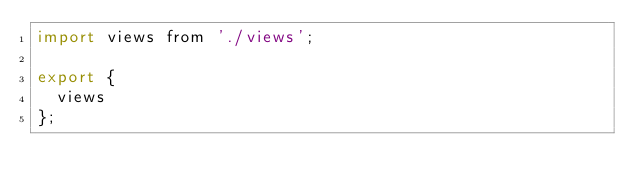Convert code to text. <code><loc_0><loc_0><loc_500><loc_500><_JavaScript_>import views from './views';

export {
  views
};
</code> 